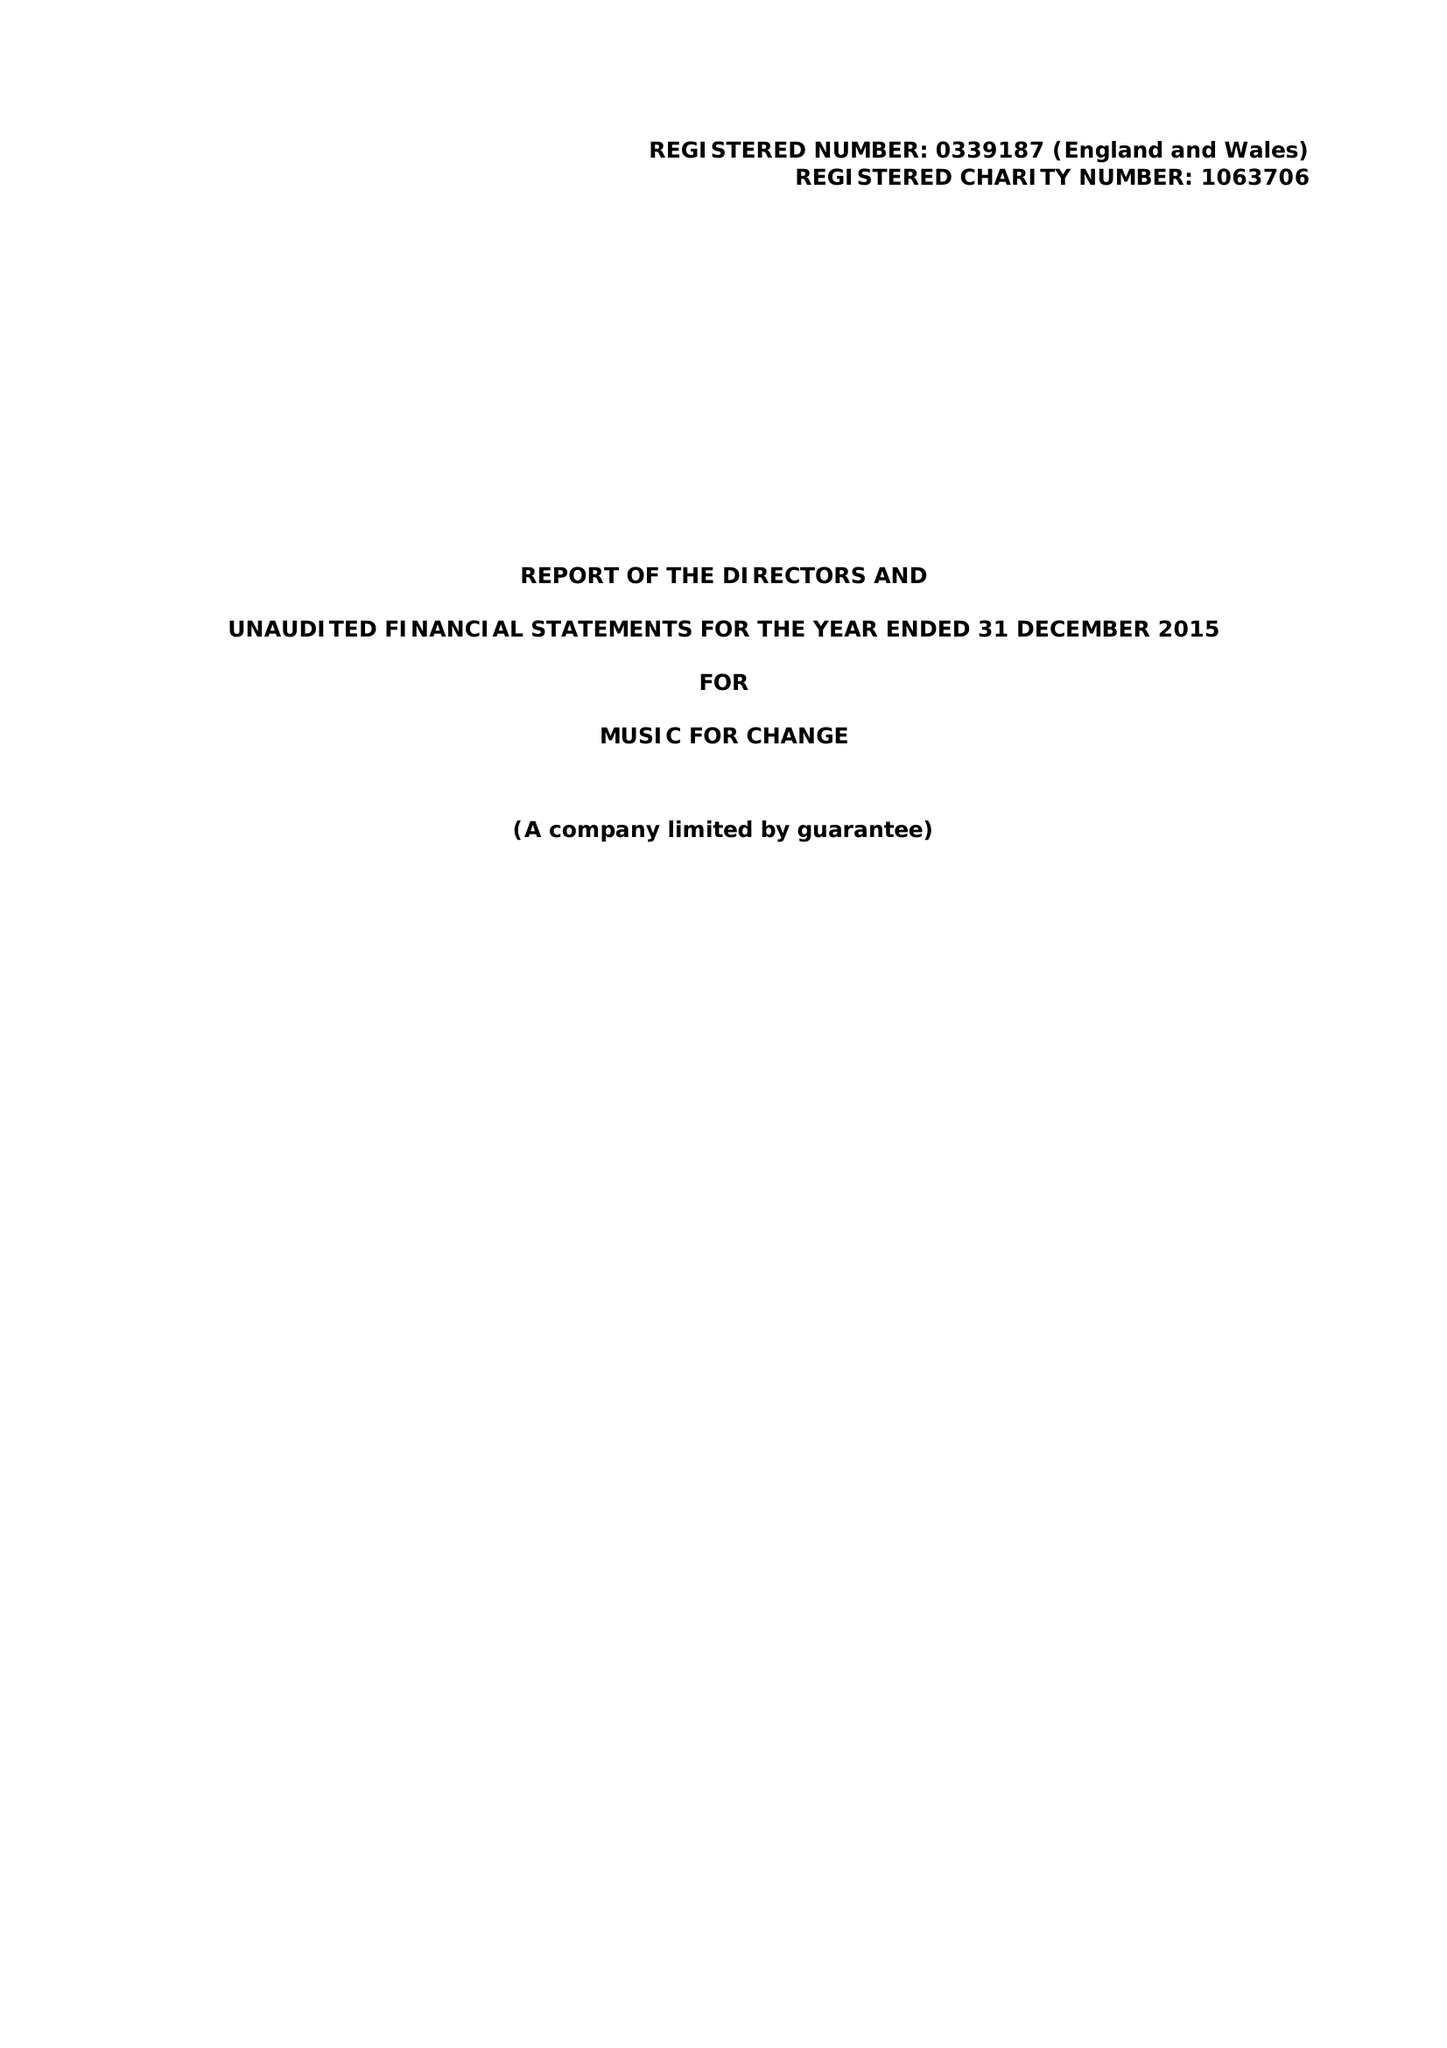What is the value for the address__postcode?
Answer the question using a single word or phrase. CT1 2NR 